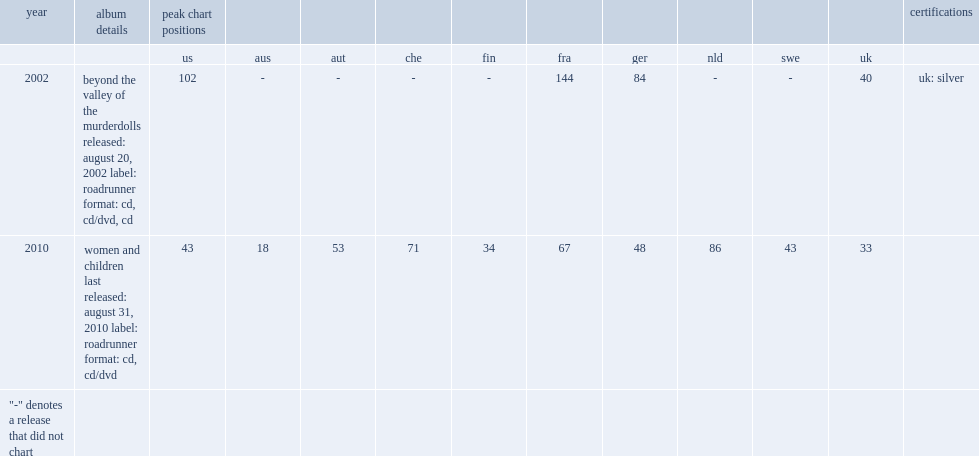What was the number of the beyond the valley album peaked at in the uk? 40.0. What was the number of the beyond the valley album peaked at in the us? 102.0. What was the number of the beyond the valley album peaked at in the france? 144.0. 